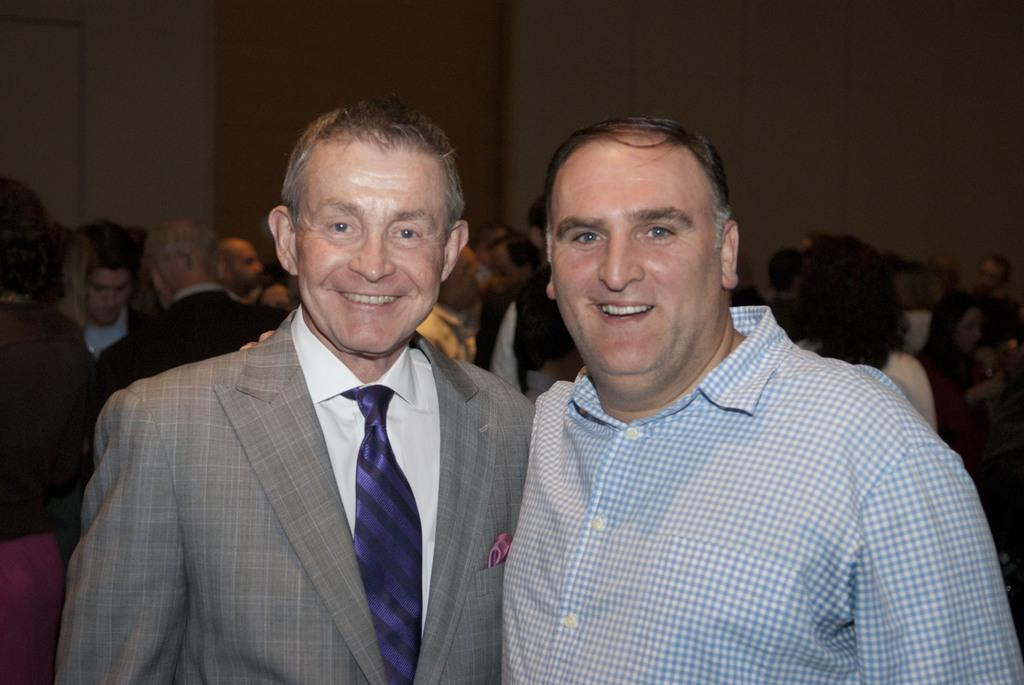How many people are in the image? There are persons in the image, but the exact number is not specified. What are the persons wearing? The persons are wearing clothes. What can be seen at the top of the image? There is a wall at the top of the image. How many ladybugs are crawling on the wall in the image? There is no mention of ladybugs in the image, so we cannot determine their presence or quantity. 